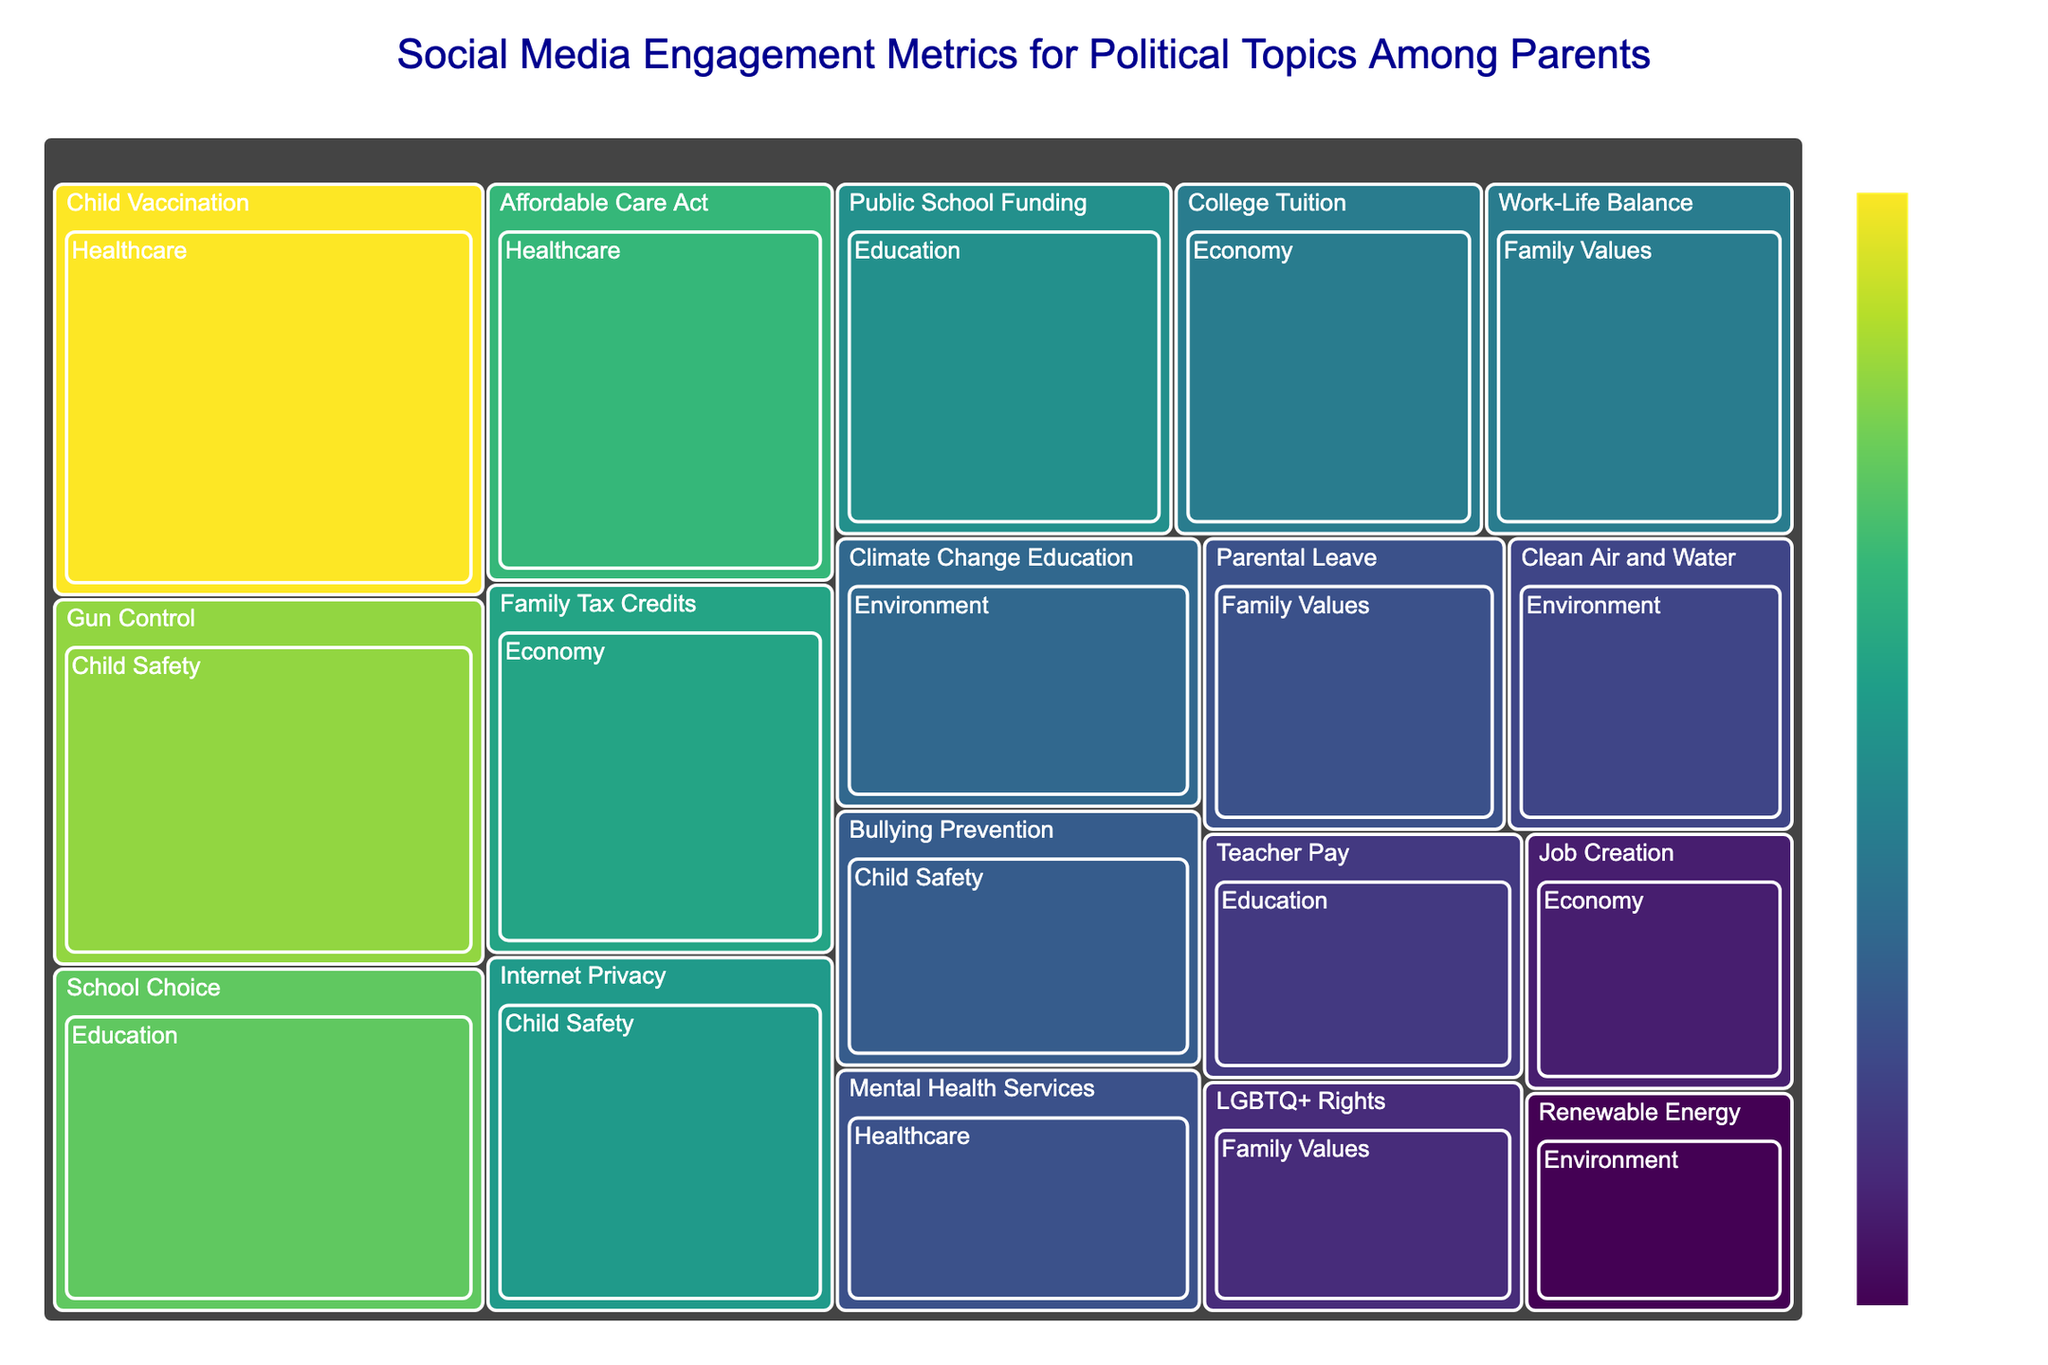Which political topic has the highest social media engagement? Look at the treemap to find the category with the largest segment, then identify the topic within this category with the highest engagement number.
Answer: Child Vaccination What is the total engagement for the topics under 'Education'? Sum the engagements of all topics under the 'Education' category: 15000 (School Choice) + 12000 (Public School Funding) + 8000 (Teacher Pay) = 35000
Answer: 35000 Which category has the lowest overall engagement, and what is its engagement number? Compare the total engagement of each category. Identify the one with the smallest sum of engagements. Add the relevant numbers for each category to verify.
Answer: Family Values, 27500 How does the engagement for 'Gun Control' compare with 'Internet Privacy'? Locate the segments for 'Gun Control' and 'Internet Privacy' under 'Child Safety' and compare their engagement numbers: 16000 (Gun Control) vs. 12500 (Internet Privacy).
Answer: Gun Control has higher engagement What is the average engagement for topics in the 'Healthcare' category? Sum the engagements of all Healthcare topics and divide by their count: (18000 + 14000 + 9000) / 3 = 41000 / 3
Answer: 13667 Which two topics under 'Economy' have the closest engagement numbers? Compare the engagement numbers for all topics under 'Economy' and identify which two values are closest to each other.
Answer: Family Tax Credits and College Tuition What is the combined engagement for 'Renewable Energy' and 'Climate Change Education'? Add the engagement numbers for 'Renewable Energy' and 'Climate Change Education': 6000 + 10000 = 16000
Answer: 16000 What color is used for the topic with the highest engagement? Identify the segment corresponding to 'Child Vaccination' and observe the color it is shaded with on the Viridis color scale, which typically progresses through shades of green and purple.
Answer: Dark green How does the engagement in 'Teacher Pay' compare with 'Bullying Prevention'? Locate the segments for 'Teacher Pay' under 'Education' and 'Bullying Prevention' under 'Child Safety', then compare their engagement values: 8000 (Teacher Pay) vs. 9500 (Bullying Prevention).
Answer: Bullying Prevention has higher engagement What is the sum of engagements for the topics categorized under 'Child Safety'? Sum the engagements of all topics under 'Child Safety': 16000 (Gun Control) + 12500 (Internet Privacy) + 9500 (Bullying Prevention) = 38000
Answer: 38000 